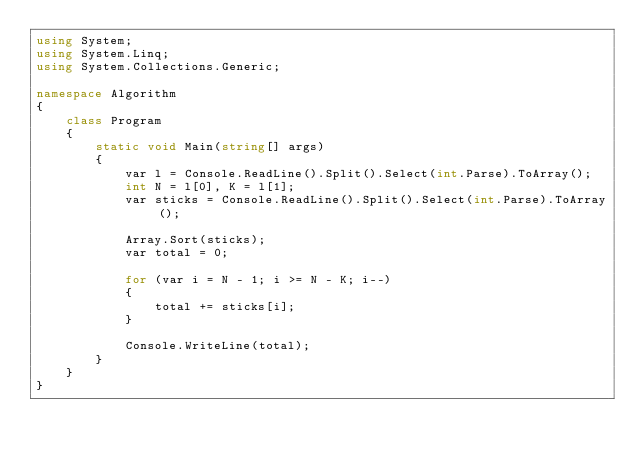<code> <loc_0><loc_0><loc_500><loc_500><_C#_>using System;
using System.Linq;
using System.Collections.Generic;

namespace Algorithm
{
    class Program
    {
        static void Main(string[] args)
        {
            var l = Console.ReadLine().Split().Select(int.Parse).ToArray();
            int N = l[0], K = l[1];
            var sticks = Console.ReadLine().Split().Select(int.Parse).ToArray();

            Array.Sort(sticks);
            var total = 0;

            for (var i = N - 1; i >= N - K; i--)
            {
                total += sticks[i];
            }

            Console.WriteLine(total);
        }
    }
}
</code> 